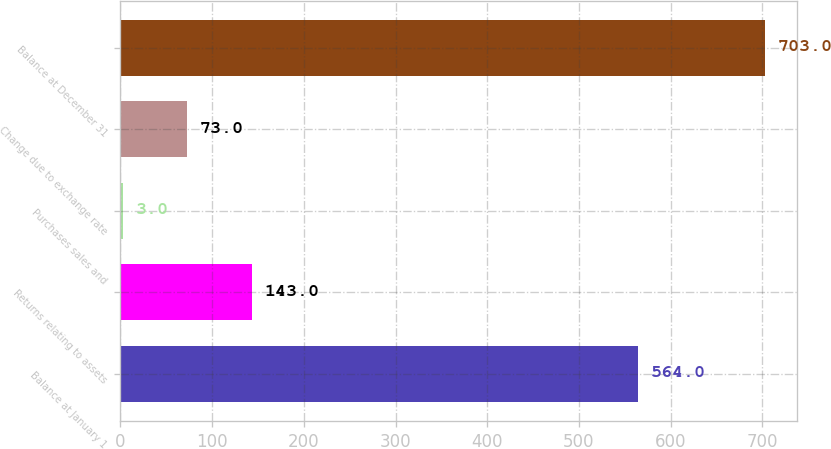Convert chart to OTSL. <chart><loc_0><loc_0><loc_500><loc_500><bar_chart><fcel>Balance at January 1<fcel>Returns relating to assets<fcel>Purchases sales and<fcel>Change due to exchange rate<fcel>Balance at December 31<nl><fcel>564<fcel>143<fcel>3<fcel>73<fcel>703<nl></chart> 